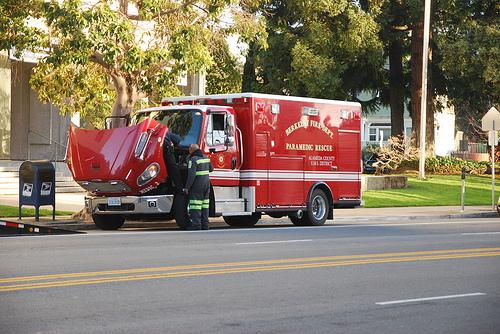Question: what is yellow?
Choices:
A. Lines on the road.
B. Ducks.
C. Wall.
D. Paint.
Answer with the letter. Answer: A Question: what is green?
Choices:
A. Pickle.
B. Paint.
C. Grass.
D. Wall.
Answer with the letter. Answer: C Question: how many trucks?
Choices:
A. One.
B. Two.
C. Three.
D. Four.
Answer with the letter. Answer: A Question: why is the hood up?
Choices:
A. Being repaired.
B. Cooling down.
C. For viewing.
D. For testing.
Answer with the letter. Answer: A 